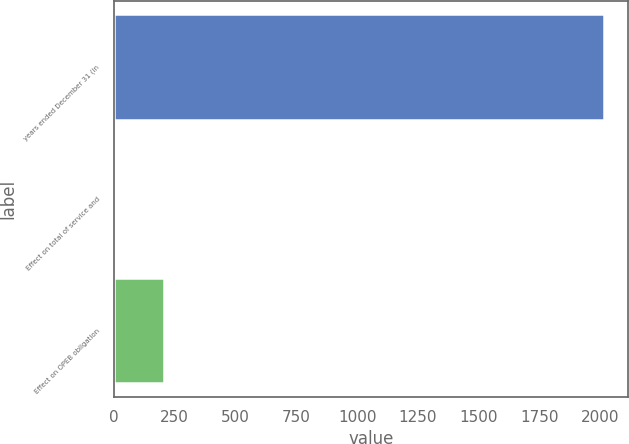<chart> <loc_0><loc_0><loc_500><loc_500><bar_chart><fcel>years ended December 31 (in<fcel>Effect on total of service and<fcel>Effect on OPEB obligation<nl><fcel>2014<fcel>4<fcel>205<nl></chart> 